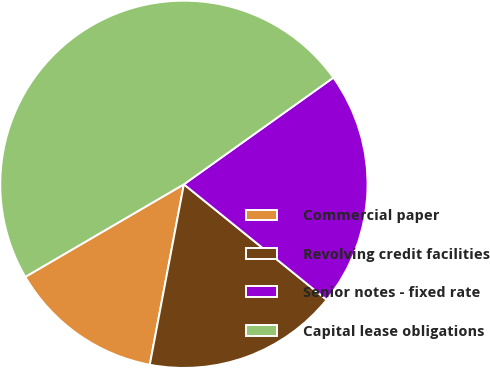Convert chart. <chart><loc_0><loc_0><loc_500><loc_500><pie_chart><fcel>Commercial paper<fcel>Revolving credit facilities<fcel>Senior notes - fixed rate<fcel>Capital lease obligations<nl><fcel>13.62%<fcel>17.15%<fcel>20.69%<fcel>48.54%<nl></chart> 